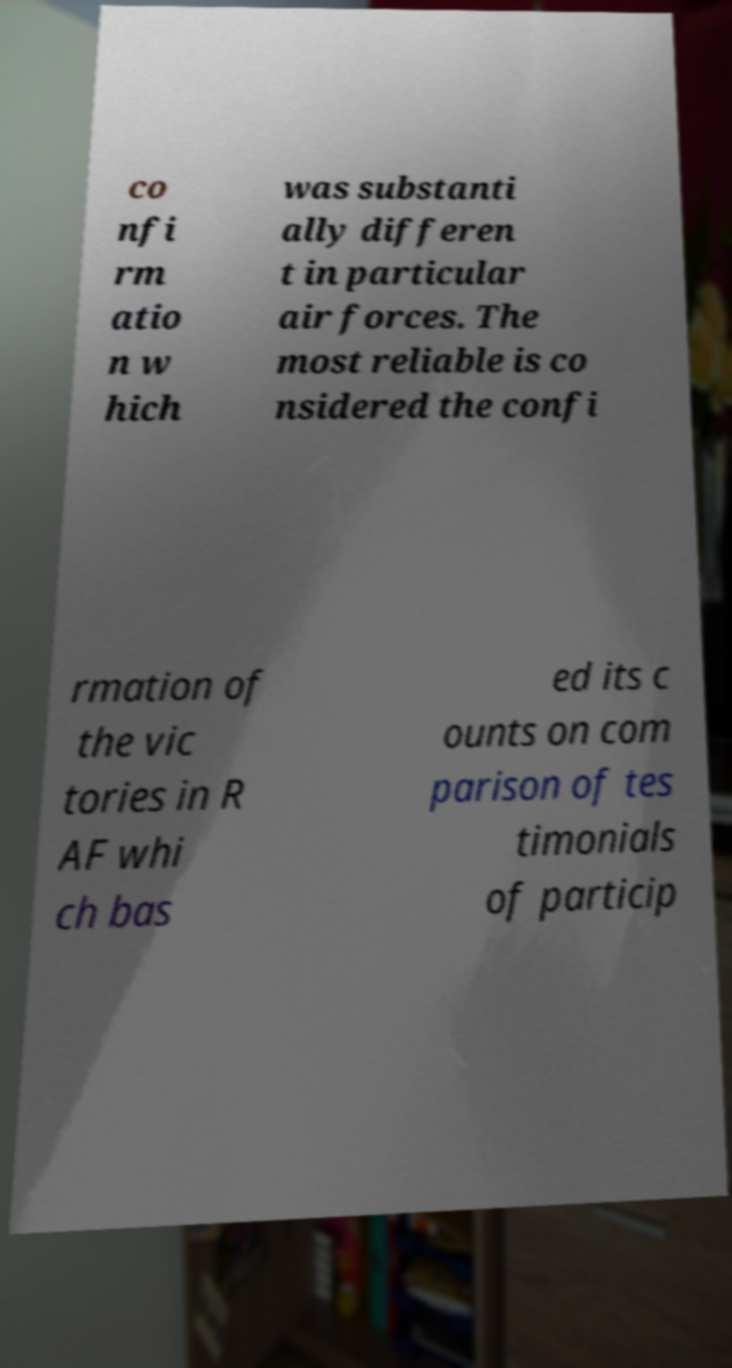Can you accurately transcribe the text from the provided image for me? co nfi rm atio n w hich was substanti ally differen t in particular air forces. The most reliable is co nsidered the confi rmation of the vic tories in R AF whi ch bas ed its c ounts on com parison of tes timonials of particip 